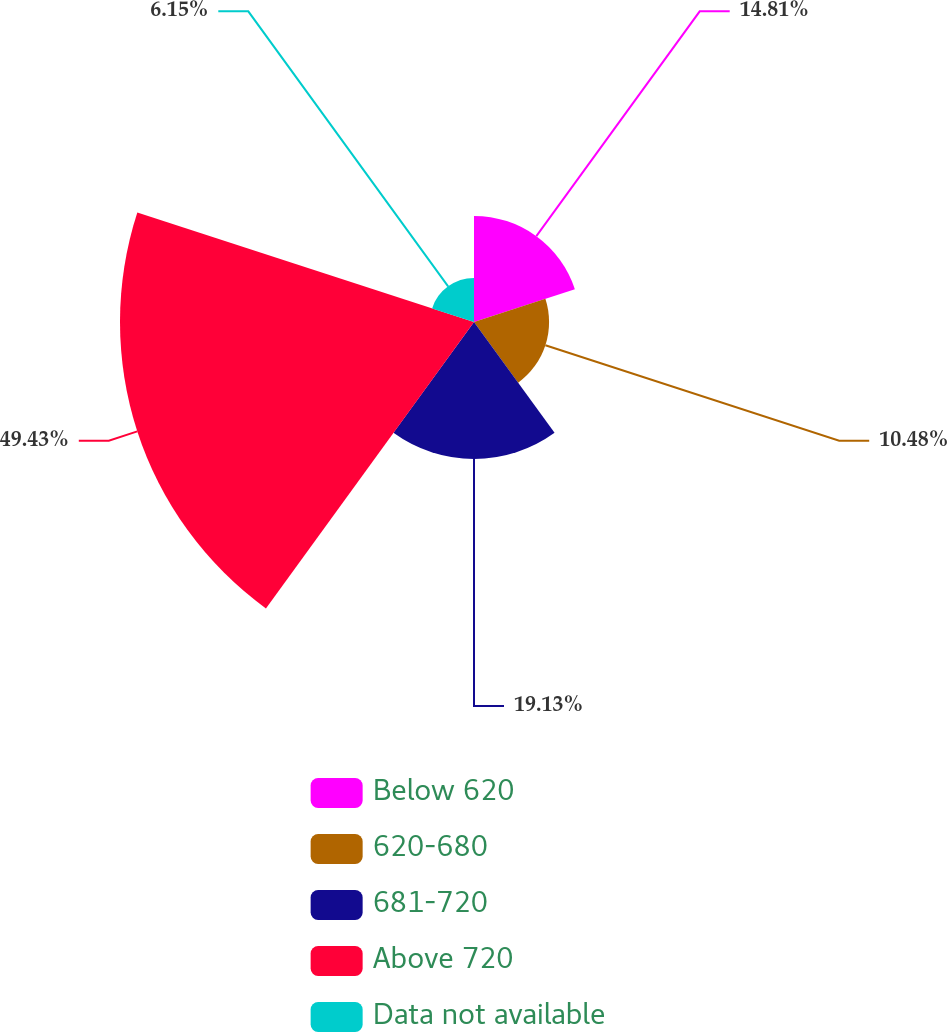<chart> <loc_0><loc_0><loc_500><loc_500><pie_chart><fcel>Below 620<fcel>620-680<fcel>681-720<fcel>Above 720<fcel>Data not available<nl><fcel>14.81%<fcel>10.48%<fcel>19.13%<fcel>49.42%<fcel>6.15%<nl></chart> 